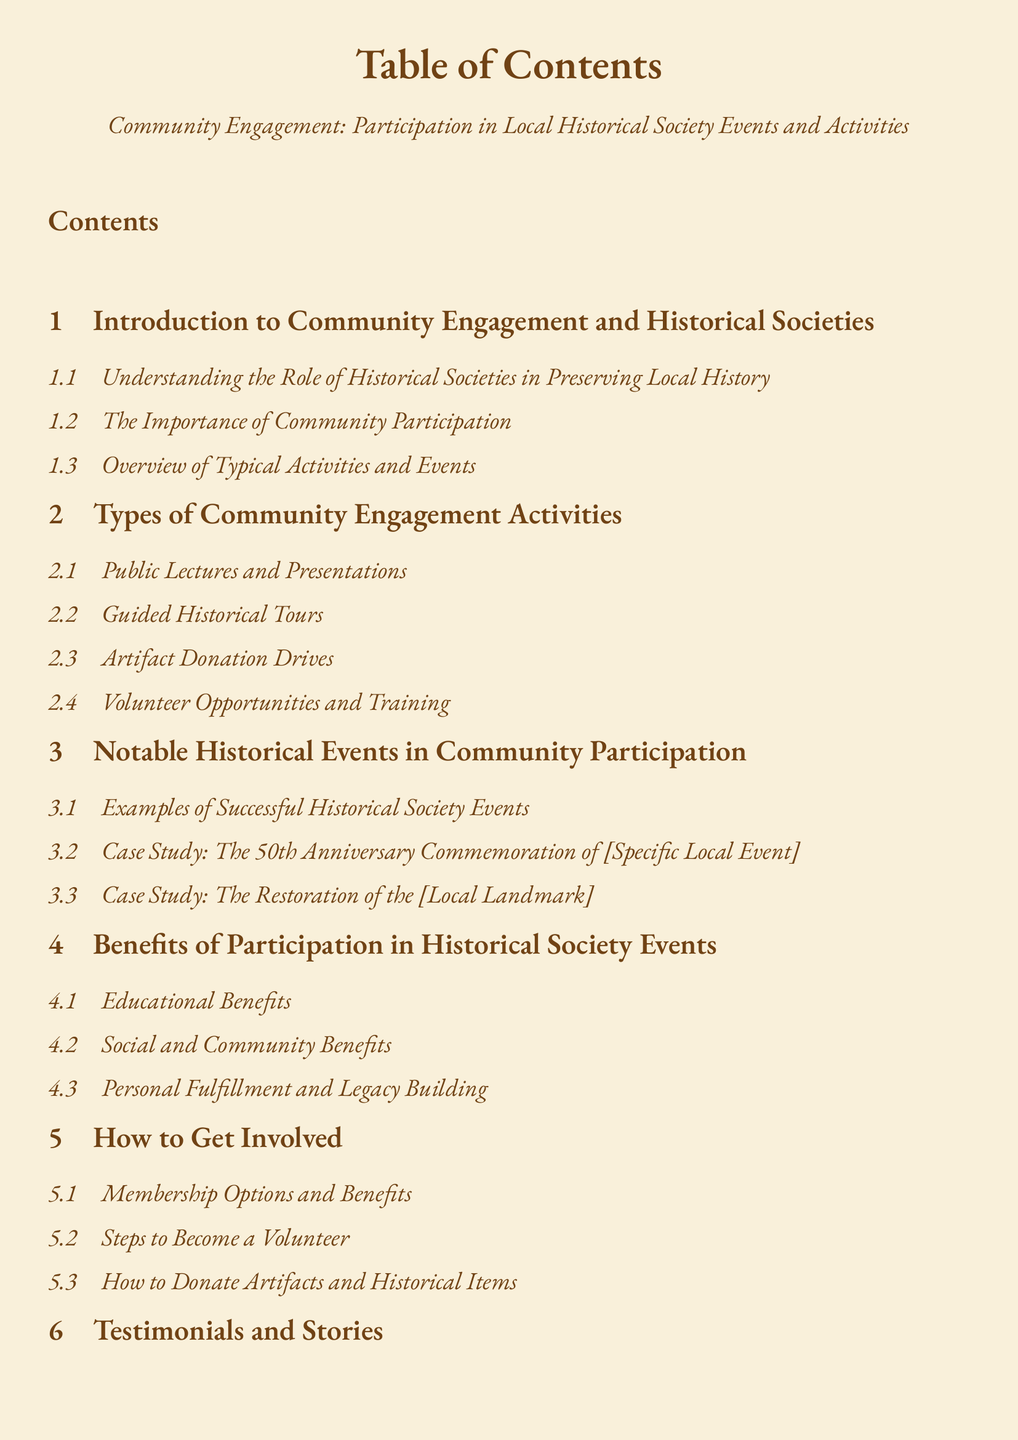what is the first section title in the document? The first section title is "Introduction to Community Engagement and Historical Societies".
Answer: Introduction to Community Engagement and Historical Societies how many types of community engagement activities are listed? There are four types listed under the "Types of Community Engagement Activities" section.
Answer: 4 what case study is mentioned related to a local event? The case study mentioned is "The 50th Anniversary Commemoration of [Specific Local Event]".
Answer: The 50th Anniversary Commemoration of [Specific Local Event] what is one of the benefits of participation in historical society events? One of the benefits listed is "Educational Benefits".
Answer: Educational Benefits what can individuals do to get involved with the historical society? Individuals can become a "Volunteer".
Answer: Volunteer what type of personal stories are included in the document? The document includes "Personal Accounts from Long-term Members".
Answer: Personal Accounts from Long-term Members how many appendices are listed in the document? There are three appendices listed at the end of the document.
Answer: 3 what is a major focus in the conclusion section? The conclusion section focuses on "Encouraging Community Involvement".
Answer: Encouraging Community Involvement 